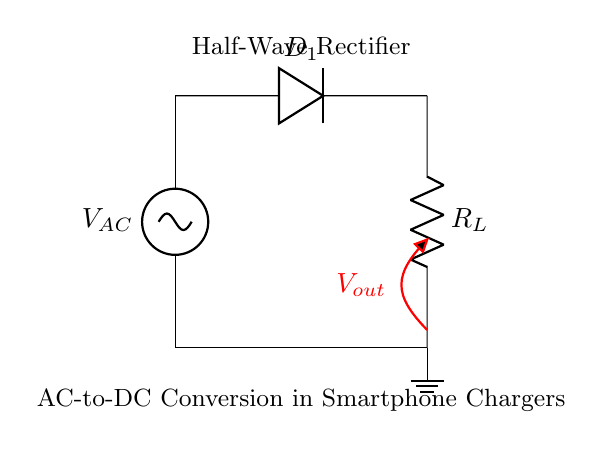What is the type of rectifier shown? The circuit displays a half-wave rectifier, which is characterized by only allowing one half of the input AC waveform to pass through while blocking the other half.
Answer: half-wave rectifier What component converts AC to DC? The diode in the circuit, labeled as D1, is responsible for converting the alternating current (AC) input into direct current (DC) by allowing current to flow in only one direction.
Answer: diode What is the role of the load resistor? The load resistor, labeled R_L, is used to limit the amount of current that can flow through the circuit and also provides a measurement point for the output voltage.
Answer: limit current What happens to the output voltage during negative cycles? During the negative cycles of the AC input, the diode is reverse-biased and does not conduct, resulting in zero output voltage. This blocking behavior prevents any negative voltage in the output.
Answer: zero output How many diodes are present in this circuit? The circuit contains one diode, which is critical for the half-wave rectification process as it allows the positive half of the AC waveform to pass while blocking the negative half.
Answer: one What is the nature of the input voltage? The input voltage, labeled as V_AC, is an alternating current (AC) supply, meaning it periodically reverses direction and varies in magnitude.
Answer: alternating current What would happen if the diode were removed from the circuit? If the diode were removed, the circuit would not be able to rectify the AC input, allowing both positive and negative halves of the waveform to pass through, resulting in an AC output instead of DC.
Answer: AC output 